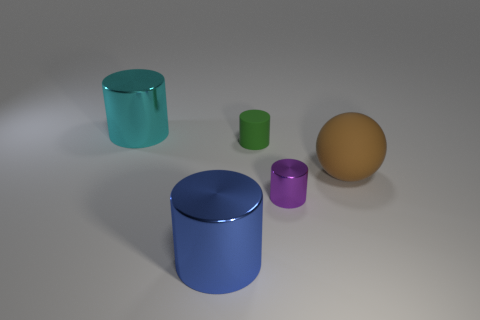There is a thing that is the same material as the large ball; what is its color?
Give a very brief answer. Green. What number of cubes are either big brown objects or large blue things?
Offer a terse response. 0. What number of things are either large blue rubber cylinders or metal objects in front of the cyan cylinder?
Ensure brevity in your answer.  2. Are any large blue metallic cylinders visible?
Give a very brief answer. Yes. What number of large metallic objects are the same color as the big rubber thing?
Ensure brevity in your answer.  0. What is the size of the thing that is in front of the small thing that is in front of the large brown ball?
Provide a succinct answer. Large. Are there any things that have the same material as the big cyan cylinder?
Offer a very short reply. Yes. What is the material of the blue thing that is the same size as the cyan metallic thing?
Your answer should be very brief. Metal. There is a large shiny cylinder to the left of the blue metal cylinder; does it have the same color as the large metal cylinder that is on the right side of the big cyan cylinder?
Offer a very short reply. No. Is there a green matte thing that is right of the green cylinder that is to the left of the brown object?
Provide a short and direct response. No. 